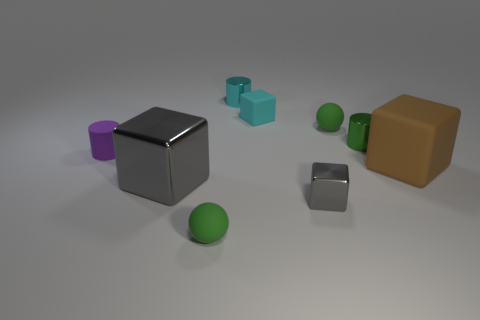There is a big metallic object that is the same color as the tiny metal cube; what shape is it?
Your answer should be compact. Cube. Is the shape of the large metallic thing the same as the green shiny object?
Make the answer very short. No. What is the color of the ball that is behind the tiny cube to the right of the small cube behind the large gray cube?
Ensure brevity in your answer.  Green. What number of other large gray objects are the same shape as the big gray metal thing?
Offer a terse response. 0. There is a rubber thing right of the small green matte sphere behind the large brown cube; what is its size?
Make the answer very short. Large. Do the brown cube and the cyan metallic cylinder have the same size?
Keep it short and to the point. No. Are there any green objects that are behind the tiny green matte ball that is to the left of the sphere that is behind the brown object?
Offer a very short reply. Yes. What is the size of the purple thing?
Give a very brief answer. Small. How many brown matte cylinders are the same size as the brown thing?
Give a very brief answer. 0. What material is the cyan object that is the same shape as the large brown matte object?
Provide a short and direct response. Rubber. 